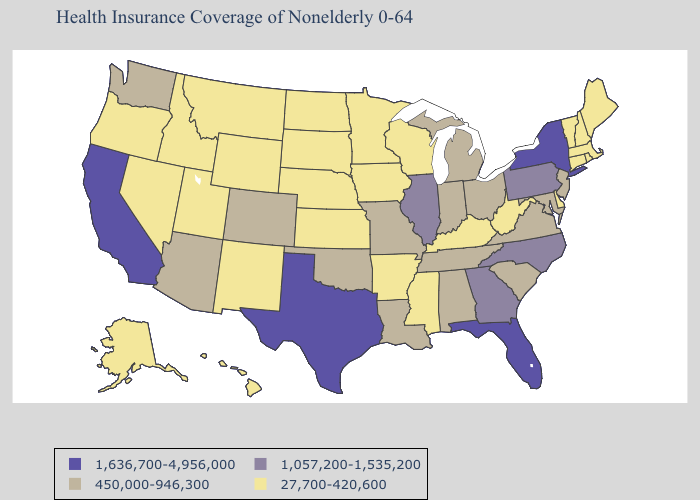Name the states that have a value in the range 1,636,700-4,956,000?
Short answer required. California, Florida, New York, Texas. What is the highest value in the USA?
Be succinct. 1,636,700-4,956,000. Does Alaska have a lower value than Alabama?
Give a very brief answer. Yes. Name the states that have a value in the range 1,057,200-1,535,200?
Give a very brief answer. Georgia, Illinois, North Carolina, Pennsylvania. Among the states that border Idaho , does Washington have the lowest value?
Be succinct. No. Name the states that have a value in the range 1,057,200-1,535,200?
Be succinct. Georgia, Illinois, North Carolina, Pennsylvania. Name the states that have a value in the range 1,636,700-4,956,000?
Give a very brief answer. California, Florida, New York, Texas. Does Kentucky have the lowest value in the South?
Keep it brief. Yes. Among the states that border Wisconsin , which have the lowest value?
Be succinct. Iowa, Minnesota. Does Idaho have the same value as Massachusetts?
Be succinct. Yes. Name the states that have a value in the range 1,636,700-4,956,000?
Keep it brief. California, Florida, New York, Texas. Which states have the highest value in the USA?
Write a very short answer. California, Florida, New York, Texas. Does the map have missing data?
Write a very short answer. No. What is the lowest value in states that border Wisconsin?
Give a very brief answer. 27,700-420,600. Which states have the lowest value in the USA?
Give a very brief answer. Alaska, Arkansas, Connecticut, Delaware, Hawaii, Idaho, Iowa, Kansas, Kentucky, Maine, Massachusetts, Minnesota, Mississippi, Montana, Nebraska, Nevada, New Hampshire, New Mexico, North Dakota, Oregon, Rhode Island, South Dakota, Utah, Vermont, West Virginia, Wisconsin, Wyoming. 